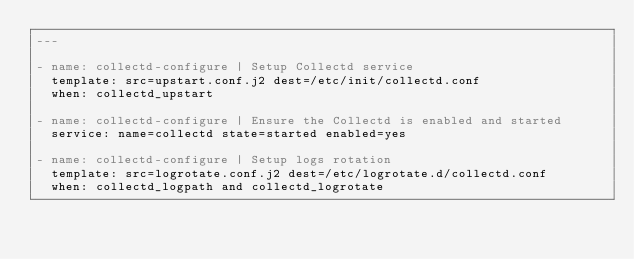Convert code to text. <code><loc_0><loc_0><loc_500><loc_500><_YAML_>---

- name: collectd-configure | Setup Collectd service
  template: src=upstart.conf.j2 dest=/etc/init/collectd.conf
  when: collectd_upstart

- name: collectd-configure | Ensure the Collectd is enabled and started
  service: name=collectd state=started enabled=yes

- name: collectd-configure | Setup logs rotation
  template: src=logrotate.conf.j2 dest=/etc/logrotate.d/collectd.conf
  when: collectd_logpath and collectd_logrotate
</code> 